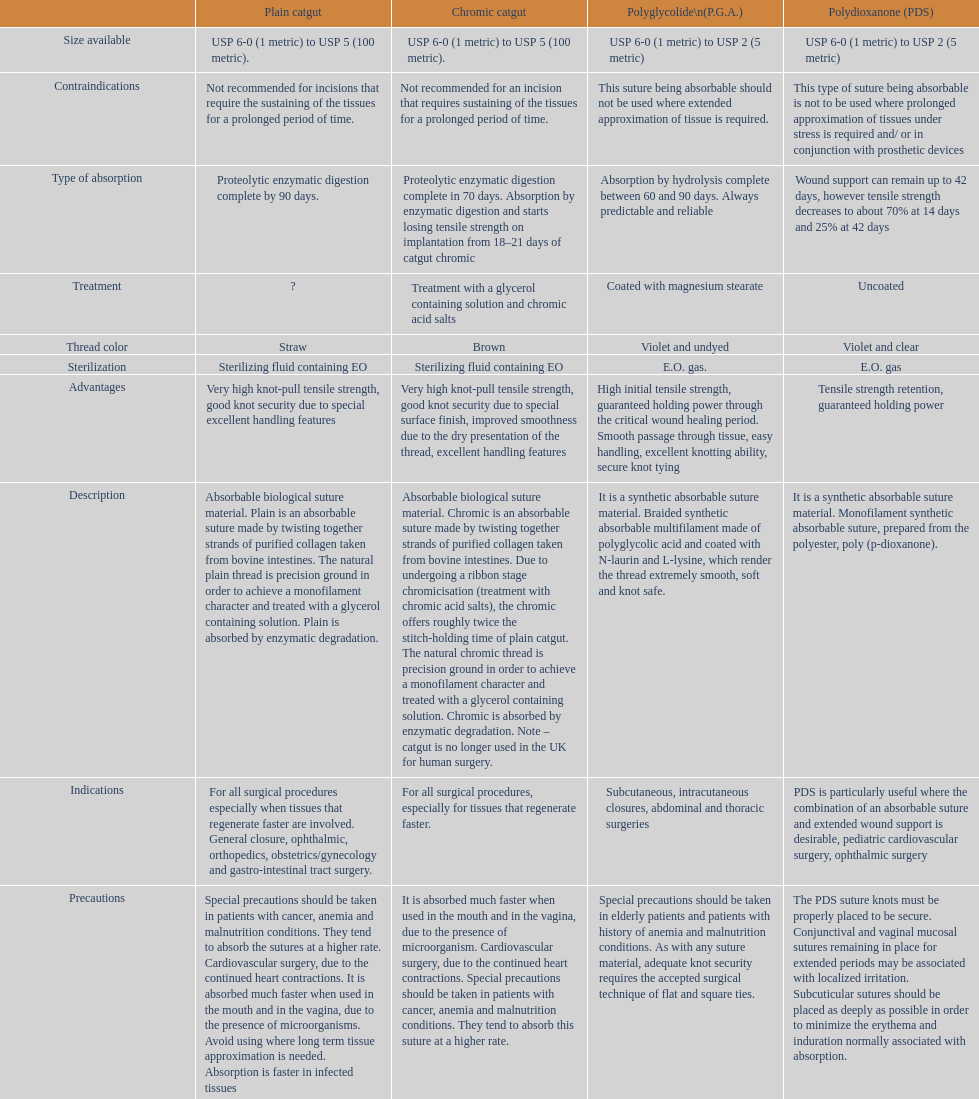What type of suture is not to be used in conjunction with prosthetic devices? Polydioxanone (PDS). 